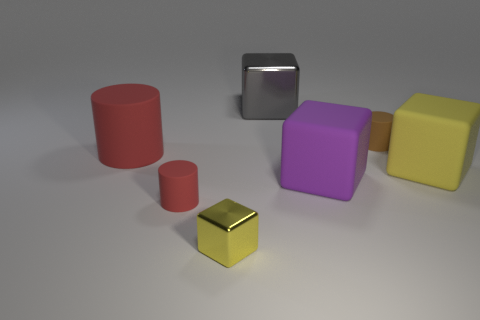Subtract all small cubes. How many cubes are left? 3 Subtract 1 cylinders. How many cylinders are left? 2 Add 2 things. How many objects exist? 9 Subtract all yellow cubes. How many cubes are left? 2 Subtract all cubes. How many objects are left? 3 Subtract all yellow cubes. How many brown cylinders are left? 1 Subtract all cyan rubber cylinders. Subtract all large gray shiny objects. How many objects are left? 6 Add 7 small yellow metal cubes. How many small yellow metal cubes are left? 8 Add 6 cubes. How many cubes exist? 10 Subtract 0 red spheres. How many objects are left? 7 